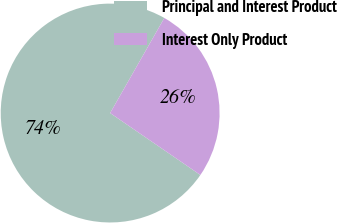<chart> <loc_0><loc_0><loc_500><loc_500><pie_chart><fcel>Principal and Interest Product<fcel>Interest Only Product<nl><fcel>73.67%<fcel>26.33%<nl></chart> 